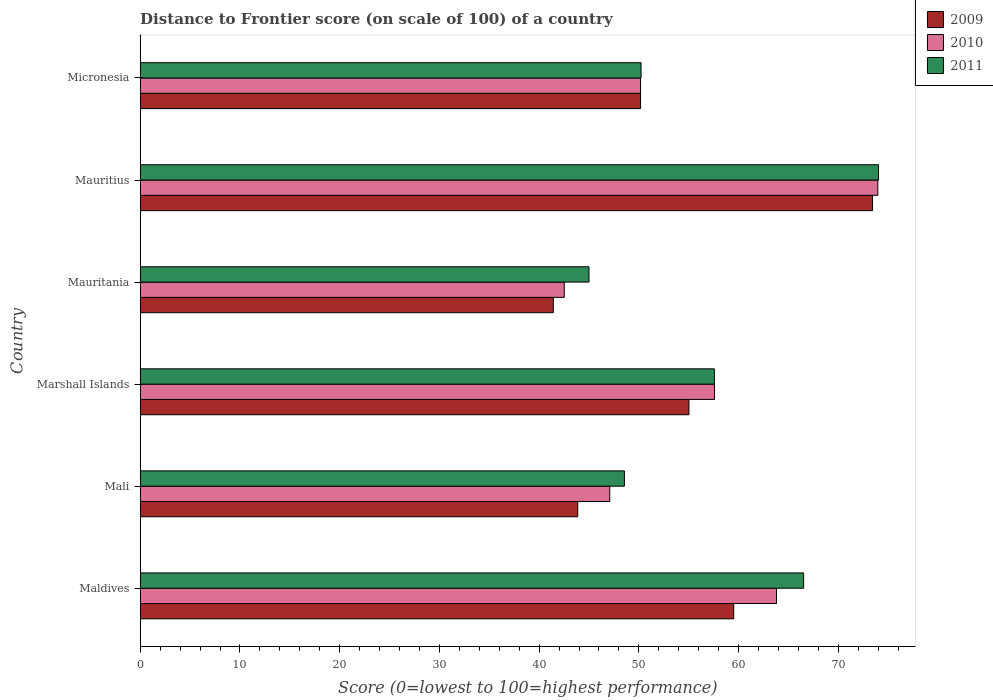How many bars are there on the 1st tick from the bottom?
Give a very brief answer. 3. What is the label of the 3rd group of bars from the top?
Provide a short and direct response. Mauritania. What is the distance to frontier score of in 2011 in Maldives?
Your answer should be compact. 66.52. Across all countries, what is the maximum distance to frontier score of in 2011?
Your answer should be compact. 74.03. In which country was the distance to frontier score of in 2009 maximum?
Offer a terse response. Mauritius. In which country was the distance to frontier score of in 2010 minimum?
Offer a terse response. Mauritania. What is the total distance to frontier score of in 2011 in the graph?
Give a very brief answer. 341.89. What is the difference between the distance to frontier score of in 2010 in Maldives and that in Micronesia?
Ensure brevity in your answer.  13.63. What is the difference between the distance to frontier score of in 2011 in Micronesia and the distance to frontier score of in 2009 in Maldives?
Give a very brief answer. -9.29. What is the average distance to frontier score of in 2010 per country?
Your response must be concise. 55.85. What is the difference between the distance to frontier score of in 2009 and distance to frontier score of in 2010 in Mauritania?
Your answer should be compact. -1.1. What is the ratio of the distance to frontier score of in 2011 in Marshall Islands to that in Mauritius?
Ensure brevity in your answer.  0.78. Is the distance to frontier score of in 2009 in Marshall Islands less than that in Mauritius?
Give a very brief answer. Yes. Is the difference between the distance to frontier score of in 2009 in Mali and Micronesia greater than the difference between the distance to frontier score of in 2010 in Mali and Micronesia?
Your answer should be compact. No. What is the difference between the highest and the second highest distance to frontier score of in 2010?
Keep it short and to the point. 10.16. What is the difference between the highest and the lowest distance to frontier score of in 2010?
Provide a short and direct response. 31.44. What does the 1st bar from the top in Mauritania represents?
Offer a very short reply. 2011. Is it the case that in every country, the sum of the distance to frontier score of in 2009 and distance to frontier score of in 2010 is greater than the distance to frontier score of in 2011?
Offer a very short reply. Yes. How many bars are there?
Provide a succinct answer. 18. What is the difference between two consecutive major ticks on the X-axis?
Make the answer very short. 10. Does the graph contain grids?
Your response must be concise. No. Where does the legend appear in the graph?
Offer a terse response. Top right. How many legend labels are there?
Your answer should be compact. 3. How are the legend labels stacked?
Provide a succinct answer. Vertical. What is the title of the graph?
Offer a terse response. Distance to Frontier score (on scale of 100) of a country. Does "2012" appear as one of the legend labels in the graph?
Your answer should be very brief. No. What is the label or title of the X-axis?
Make the answer very short. Score (0=lowest to 100=highest performance). What is the label or title of the Y-axis?
Offer a very short reply. Country. What is the Score (0=lowest to 100=highest performance) of 2009 in Maldives?
Give a very brief answer. 59.51. What is the Score (0=lowest to 100=highest performance) of 2010 in Maldives?
Give a very brief answer. 63.8. What is the Score (0=lowest to 100=highest performance) in 2011 in Maldives?
Give a very brief answer. 66.52. What is the Score (0=lowest to 100=highest performance) in 2009 in Mali?
Your response must be concise. 43.87. What is the Score (0=lowest to 100=highest performance) in 2010 in Mali?
Offer a very short reply. 47.08. What is the Score (0=lowest to 100=highest performance) in 2011 in Mali?
Your answer should be compact. 48.55. What is the Score (0=lowest to 100=highest performance) in 2009 in Marshall Islands?
Offer a terse response. 55.02. What is the Score (0=lowest to 100=highest performance) in 2010 in Marshall Islands?
Your answer should be compact. 57.58. What is the Score (0=lowest to 100=highest performance) of 2011 in Marshall Islands?
Keep it short and to the point. 57.57. What is the Score (0=lowest to 100=highest performance) in 2009 in Mauritania?
Your response must be concise. 41.42. What is the Score (0=lowest to 100=highest performance) of 2010 in Mauritania?
Your answer should be compact. 42.52. What is the Score (0=lowest to 100=highest performance) of 2011 in Mauritania?
Your answer should be compact. 45. What is the Score (0=lowest to 100=highest performance) of 2009 in Mauritius?
Make the answer very short. 73.43. What is the Score (0=lowest to 100=highest performance) of 2010 in Mauritius?
Ensure brevity in your answer.  73.96. What is the Score (0=lowest to 100=highest performance) in 2011 in Mauritius?
Provide a succinct answer. 74.03. What is the Score (0=lowest to 100=highest performance) in 2009 in Micronesia?
Provide a short and direct response. 50.17. What is the Score (0=lowest to 100=highest performance) in 2010 in Micronesia?
Offer a very short reply. 50.17. What is the Score (0=lowest to 100=highest performance) in 2011 in Micronesia?
Your answer should be compact. 50.22. Across all countries, what is the maximum Score (0=lowest to 100=highest performance) in 2009?
Your response must be concise. 73.43. Across all countries, what is the maximum Score (0=lowest to 100=highest performance) of 2010?
Your response must be concise. 73.96. Across all countries, what is the maximum Score (0=lowest to 100=highest performance) of 2011?
Keep it short and to the point. 74.03. Across all countries, what is the minimum Score (0=lowest to 100=highest performance) of 2009?
Ensure brevity in your answer.  41.42. Across all countries, what is the minimum Score (0=lowest to 100=highest performance) of 2010?
Make the answer very short. 42.52. What is the total Score (0=lowest to 100=highest performance) of 2009 in the graph?
Give a very brief answer. 323.42. What is the total Score (0=lowest to 100=highest performance) of 2010 in the graph?
Ensure brevity in your answer.  335.11. What is the total Score (0=lowest to 100=highest performance) in 2011 in the graph?
Ensure brevity in your answer.  341.89. What is the difference between the Score (0=lowest to 100=highest performance) in 2009 in Maldives and that in Mali?
Your response must be concise. 15.64. What is the difference between the Score (0=lowest to 100=highest performance) in 2010 in Maldives and that in Mali?
Your response must be concise. 16.72. What is the difference between the Score (0=lowest to 100=highest performance) in 2011 in Maldives and that in Mali?
Provide a succinct answer. 17.97. What is the difference between the Score (0=lowest to 100=highest performance) in 2009 in Maldives and that in Marshall Islands?
Your answer should be compact. 4.49. What is the difference between the Score (0=lowest to 100=highest performance) in 2010 in Maldives and that in Marshall Islands?
Keep it short and to the point. 6.22. What is the difference between the Score (0=lowest to 100=highest performance) in 2011 in Maldives and that in Marshall Islands?
Offer a terse response. 8.95. What is the difference between the Score (0=lowest to 100=highest performance) of 2009 in Maldives and that in Mauritania?
Your answer should be very brief. 18.09. What is the difference between the Score (0=lowest to 100=highest performance) of 2010 in Maldives and that in Mauritania?
Offer a terse response. 21.28. What is the difference between the Score (0=lowest to 100=highest performance) in 2011 in Maldives and that in Mauritania?
Your answer should be compact. 21.52. What is the difference between the Score (0=lowest to 100=highest performance) in 2009 in Maldives and that in Mauritius?
Give a very brief answer. -13.92. What is the difference between the Score (0=lowest to 100=highest performance) in 2010 in Maldives and that in Mauritius?
Your answer should be compact. -10.16. What is the difference between the Score (0=lowest to 100=highest performance) in 2011 in Maldives and that in Mauritius?
Give a very brief answer. -7.51. What is the difference between the Score (0=lowest to 100=highest performance) in 2009 in Maldives and that in Micronesia?
Your answer should be compact. 9.34. What is the difference between the Score (0=lowest to 100=highest performance) in 2010 in Maldives and that in Micronesia?
Your answer should be compact. 13.63. What is the difference between the Score (0=lowest to 100=highest performance) in 2011 in Maldives and that in Micronesia?
Provide a short and direct response. 16.3. What is the difference between the Score (0=lowest to 100=highest performance) in 2009 in Mali and that in Marshall Islands?
Provide a succinct answer. -11.15. What is the difference between the Score (0=lowest to 100=highest performance) of 2011 in Mali and that in Marshall Islands?
Your response must be concise. -9.02. What is the difference between the Score (0=lowest to 100=highest performance) of 2009 in Mali and that in Mauritania?
Provide a short and direct response. 2.45. What is the difference between the Score (0=lowest to 100=highest performance) of 2010 in Mali and that in Mauritania?
Offer a terse response. 4.56. What is the difference between the Score (0=lowest to 100=highest performance) in 2011 in Mali and that in Mauritania?
Your response must be concise. 3.55. What is the difference between the Score (0=lowest to 100=highest performance) of 2009 in Mali and that in Mauritius?
Offer a very short reply. -29.56. What is the difference between the Score (0=lowest to 100=highest performance) of 2010 in Mali and that in Mauritius?
Your answer should be very brief. -26.88. What is the difference between the Score (0=lowest to 100=highest performance) of 2011 in Mali and that in Mauritius?
Ensure brevity in your answer.  -25.48. What is the difference between the Score (0=lowest to 100=highest performance) in 2009 in Mali and that in Micronesia?
Your answer should be very brief. -6.3. What is the difference between the Score (0=lowest to 100=highest performance) in 2010 in Mali and that in Micronesia?
Your answer should be compact. -3.09. What is the difference between the Score (0=lowest to 100=highest performance) of 2011 in Mali and that in Micronesia?
Make the answer very short. -1.67. What is the difference between the Score (0=lowest to 100=highest performance) of 2009 in Marshall Islands and that in Mauritania?
Keep it short and to the point. 13.6. What is the difference between the Score (0=lowest to 100=highest performance) of 2010 in Marshall Islands and that in Mauritania?
Give a very brief answer. 15.06. What is the difference between the Score (0=lowest to 100=highest performance) in 2011 in Marshall Islands and that in Mauritania?
Offer a terse response. 12.57. What is the difference between the Score (0=lowest to 100=highest performance) of 2009 in Marshall Islands and that in Mauritius?
Provide a short and direct response. -18.41. What is the difference between the Score (0=lowest to 100=highest performance) of 2010 in Marshall Islands and that in Mauritius?
Provide a succinct answer. -16.38. What is the difference between the Score (0=lowest to 100=highest performance) in 2011 in Marshall Islands and that in Mauritius?
Offer a terse response. -16.46. What is the difference between the Score (0=lowest to 100=highest performance) of 2009 in Marshall Islands and that in Micronesia?
Provide a short and direct response. 4.85. What is the difference between the Score (0=lowest to 100=highest performance) in 2010 in Marshall Islands and that in Micronesia?
Keep it short and to the point. 7.41. What is the difference between the Score (0=lowest to 100=highest performance) in 2011 in Marshall Islands and that in Micronesia?
Keep it short and to the point. 7.35. What is the difference between the Score (0=lowest to 100=highest performance) in 2009 in Mauritania and that in Mauritius?
Ensure brevity in your answer.  -32.01. What is the difference between the Score (0=lowest to 100=highest performance) of 2010 in Mauritania and that in Mauritius?
Your response must be concise. -31.44. What is the difference between the Score (0=lowest to 100=highest performance) in 2011 in Mauritania and that in Mauritius?
Provide a succinct answer. -29.03. What is the difference between the Score (0=lowest to 100=highest performance) in 2009 in Mauritania and that in Micronesia?
Your response must be concise. -8.75. What is the difference between the Score (0=lowest to 100=highest performance) of 2010 in Mauritania and that in Micronesia?
Offer a terse response. -7.65. What is the difference between the Score (0=lowest to 100=highest performance) of 2011 in Mauritania and that in Micronesia?
Keep it short and to the point. -5.22. What is the difference between the Score (0=lowest to 100=highest performance) in 2009 in Mauritius and that in Micronesia?
Provide a short and direct response. 23.26. What is the difference between the Score (0=lowest to 100=highest performance) of 2010 in Mauritius and that in Micronesia?
Provide a succinct answer. 23.79. What is the difference between the Score (0=lowest to 100=highest performance) in 2011 in Mauritius and that in Micronesia?
Your answer should be very brief. 23.81. What is the difference between the Score (0=lowest to 100=highest performance) of 2009 in Maldives and the Score (0=lowest to 100=highest performance) of 2010 in Mali?
Provide a short and direct response. 12.43. What is the difference between the Score (0=lowest to 100=highest performance) in 2009 in Maldives and the Score (0=lowest to 100=highest performance) in 2011 in Mali?
Offer a terse response. 10.96. What is the difference between the Score (0=lowest to 100=highest performance) in 2010 in Maldives and the Score (0=lowest to 100=highest performance) in 2011 in Mali?
Keep it short and to the point. 15.25. What is the difference between the Score (0=lowest to 100=highest performance) of 2009 in Maldives and the Score (0=lowest to 100=highest performance) of 2010 in Marshall Islands?
Provide a succinct answer. 1.93. What is the difference between the Score (0=lowest to 100=highest performance) of 2009 in Maldives and the Score (0=lowest to 100=highest performance) of 2011 in Marshall Islands?
Provide a short and direct response. 1.94. What is the difference between the Score (0=lowest to 100=highest performance) of 2010 in Maldives and the Score (0=lowest to 100=highest performance) of 2011 in Marshall Islands?
Keep it short and to the point. 6.23. What is the difference between the Score (0=lowest to 100=highest performance) in 2009 in Maldives and the Score (0=lowest to 100=highest performance) in 2010 in Mauritania?
Your response must be concise. 16.99. What is the difference between the Score (0=lowest to 100=highest performance) of 2009 in Maldives and the Score (0=lowest to 100=highest performance) of 2011 in Mauritania?
Keep it short and to the point. 14.51. What is the difference between the Score (0=lowest to 100=highest performance) of 2010 in Maldives and the Score (0=lowest to 100=highest performance) of 2011 in Mauritania?
Your answer should be compact. 18.8. What is the difference between the Score (0=lowest to 100=highest performance) of 2009 in Maldives and the Score (0=lowest to 100=highest performance) of 2010 in Mauritius?
Ensure brevity in your answer.  -14.45. What is the difference between the Score (0=lowest to 100=highest performance) of 2009 in Maldives and the Score (0=lowest to 100=highest performance) of 2011 in Mauritius?
Your response must be concise. -14.52. What is the difference between the Score (0=lowest to 100=highest performance) in 2010 in Maldives and the Score (0=lowest to 100=highest performance) in 2011 in Mauritius?
Keep it short and to the point. -10.23. What is the difference between the Score (0=lowest to 100=highest performance) of 2009 in Maldives and the Score (0=lowest to 100=highest performance) of 2010 in Micronesia?
Make the answer very short. 9.34. What is the difference between the Score (0=lowest to 100=highest performance) in 2009 in Maldives and the Score (0=lowest to 100=highest performance) in 2011 in Micronesia?
Offer a terse response. 9.29. What is the difference between the Score (0=lowest to 100=highest performance) in 2010 in Maldives and the Score (0=lowest to 100=highest performance) in 2011 in Micronesia?
Offer a very short reply. 13.58. What is the difference between the Score (0=lowest to 100=highest performance) of 2009 in Mali and the Score (0=lowest to 100=highest performance) of 2010 in Marshall Islands?
Keep it short and to the point. -13.71. What is the difference between the Score (0=lowest to 100=highest performance) in 2009 in Mali and the Score (0=lowest to 100=highest performance) in 2011 in Marshall Islands?
Provide a succinct answer. -13.7. What is the difference between the Score (0=lowest to 100=highest performance) in 2010 in Mali and the Score (0=lowest to 100=highest performance) in 2011 in Marshall Islands?
Give a very brief answer. -10.49. What is the difference between the Score (0=lowest to 100=highest performance) of 2009 in Mali and the Score (0=lowest to 100=highest performance) of 2010 in Mauritania?
Provide a succinct answer. 1.35. What is the difference between the Score (0=lowest to 100=highest performance) of 2009 in Mali and the Score (0=lowest to 100=highest performance) of 2011 in Mauritania?
Provide a short and direct response. -1.13. What is the difference between the Score (0=lowest to 100=highest performance) in 2010 in Mali and the Score (0=lowest to 100=highest performance) in 2011 in Mauritania?
Provide a succinct answer. 2.08. What is the difference between the Score (0=lowest to 100=highest performance) of 2009 in Mali and the Score (0=lowest to 100=highest performance) of 2010 in Mauritius?
Offer a very short reply. -30.09. What is the difference between the Score (0=lowest to 100=highest performance) of 2009 in Mali and the Score (0=lowest to 100=highest performance) of 2011 in Mauritius?
Your answer should be compact. -30.16. What is the difference between the Score (0=lowest to 100=highest performance) in 2010 in Mali and the Score (0=lowest to 100=highest performance) in 2011 in Mauritius?
Your answer should be very brief. -26.95. What is the difference between the Score (0=lowest to 100=highest performance) of 2009 in Mali and the Score (0=lowest to 100=highest performance) of 2011 in Micronesia?
Give a very brief answer. -6.35. What is the difference between the Score (0=lowest to 100=highest performance) of 2010 in Mali and the Score (0=lowest to 100=highest performance) of 2011 in Micronesia?
Offer a terse response. -3.14. What is the difference between the Score (0=lowest to 100=highest performance) in 2009 in Marshall Islands and the Score (0=lowest to 100=highest performance) in 2010 in Mauritania?
Your response must be concise. 12.5. What is the difference between the Score (0=lowest to 100=highest performance) of 2009 in Marshall Islands and the Score (0=lowest to 100=highest performance) of 2011 in Mauritania?
Keep it short and to the point. 10.02. What is the difference between the Score (0=lowest to 100=highest performance) in 2010 in Marshall Islands and the Score (0=lowest to 100=highest performance) in 2011 in Mauritania?
Your answer should be very brief. 12.58. What is the difference between the Score (0=lowest to 100=highest performance) of 2009 in Marshall Islands and the Score (0=lowest to 100=highest performance) of 2010 in Mauritius?
Keep it short and to the point. -18.94. What is the difference between the Score (0=lowest to 100=highest performance) in 2009 in Marshall Islands and the Score (0=lowest to 100=highest performance) in 2011 in Mauritius?
Give a very brief answer. -19.01. What is the difference between the Score (0=lowest to 100=highest performance) in 2010 in Marshall Islands and the Score (0=lowest to 100=highest performance) in 2011 in Mauritius?
Your response must be concise. -16.45. What is the difference between the Score (0=lowest to 100=highest performance) in 2009 in Marshall Islands and the Score (0=lowest to 100=highest performance) in 2010 in Micronesia?
Ensure brevity in your answer.  4.85. What is the difference between the Score (0=lowest to 100=highest performance) in 2009 in Marshall Islands and the Score (0=lowest to 100=highest performance) in 2011 in Micronesia?
Keep it short and to the point. 4.8. What is the difference between the Score (0=lowest to 100=highest performance) of 2010 in Marshall Islands and the Score (0=lowest to 100=highest performance) of 2011 in Micronesia?
Keep it short and to the point. 7.36. What is the difference between the Score (0=lowest to 100=highest performance) in 2009 in Mauritania and the Score (0=lowest to 100=highest performance) in 2010 in Mauritius?
Offer a terse response. -32.54. What is the difference between the Score (0=lowest to 100=highest performance) of 2009 in Mauritania and the Score (0=lowest to 100=highest performance) of 2011 in Mauritius?
Give a very brief answer. -32.61. What is the difference between the Score (0=lowest to 100=highest performance) of 2010 in Mauritania and the Score (0=lowest to 100=highest performance) of 2011 in Mauritius?
Your response must be concise. -31.51. What is the difference between the Score (0=lowest to 100=highest performance) of 2009 in Mauritania and the Score (0=lowest to 100=highest performance) of 2010 in Micronesia?
Give a very brief answer. -8.75. What is the difference between the Score (0=lowest to 100=highest performance) in 2009 in Mauritania and the Score (0=lowest to 100=highest performance) in 2011 in Micronesia?
Your answer should be very brief. -8.8. What is the difference between the Score (0=lowest to 100=highest performance) of 2009 in Mauritius and the Score (0=lowest to 100=highest performance) of 2010 in Micronesia?
Ensure brevity in your answer.  23.26. What is the difference between the Score (0=lowest to 100=highest performance) of 2009 in Mauritius and the Score (0=lowest to 100=highest performance) of 2011 in Micronesia?
Your response must be concise. 23.21. What is the difference between the Score (0=lowest to 100=highest performance) of 2010 in Mauritius and the Score (0=lowest to 100=highest performance) of 2011 in Micronesia?
Your answer should be very brief. 23.74. What is the average Score (0=lowest to 100=highest performance) in 2009 per country?
Ensure brevity in your answer.  53.9. What is the average Score (0=lowest to 100=highest performance) in 2010 per country?
Your response must be concise. 55.85. What is the average Score (0=lowest to 100=highest performance) in 2011 per country?
Your answer should be very brief. 56.98. What is the difference between the Score (0=lowest to 100=highest performance) in 2009 and Score (0=lowest to 100=highest performance) in 2010 in Maldives?
Give a very brief answer. -4.29. What is the difference between the Score (0=lowest to 100=highest performance) in 2009 and Score (0=lowest to 100=highest performance) in 2011 in Maldives?
Give a very brief answer. -7.01. What is the difference between the Score (0=lowest to 100=highest performance) in 2010 and Score (0=lowest to 100=highest performance) in 2011 in Maldives?
Provide a short and direct response. -2.72. What is the difference between the Score (0=lowest to 100=highest performance) of 2009 and Score (0=lowest to 100=highest performance) of 2010 in Mali?
Keep it short and to the point. -3.21. What is the difference between the Score (0=lowest to 100=highest performance) of 2009 and Score (0=lowest to 100=highest performance) of 2011 in Mali?
Provide a short and direct response. -4.68. What is the difference between the Score (0=lowest to 100=highest performance) in 2010 and Score (0=lowest to 100=highest performance) in 2011 in Mali?
Your response must be concise. -1.47. What is the difference between the Score (0=lowest to 100=highest performance) in 2009 and Score (0=lowest to 100=highest performance) in 2010 in Marshall Islands?
Provide a succinct answer. -2.56. What is the difference between the Score (0=lowest to 100=highest performance) in 2009 and Score (0=lowest to 100=highest performance) in 2011 in Marshall Islands?
Offer a very short reply. -2.55. What is the difference between the Score (0=lowest to 100=highest performance) of 2010 and Score (0=lowest to 100=highest performance) of 2011 in Marshall Islands?
Provide a short and direct response. 0.01. What is the difference between the Score (0=lowest to 100=highest performance) of 2009 and Score (0=lowest to 100=highest performance) of 2011 in Mauritania?
Provide a short and direct response. -3.58. What is the difference between the Score (0=lowest to 100=highest performance) in 2010 and Score (0=lowest to 100=highest performance) in 2011 in Mauritania?
Offer a very short reply. -2.48. What is the difference between the Score (0=lowest to 100=highest performance) of 2009 and Score (0=lowest to 100=highest performance) of 2010 in Mauritius?
Your response must be concise. -0.53. What is the difference between the Score (0=lowest to 100=highest performance) in 2010 and Score (0=lowest to 100=highest performance) in 2011 in Mauritius?
Offer a very short reply. -0.07. What is the ratio of the Score (0=lowest to 100=highest performance) in 2009 in Maldives to that in Mali?
Your answer should be compact. 1.36. What is the ratio of the Score (0=lowest to 100=highest performance) of 2010 in Maldives to that in Mali?
Make the answer very short. 1.36. What is the ratio of the Score (0=lowest to 100=highest performance) of 2011 in Maldives to that in Mali?
Provide a short and direct response. 1.37. What is the ratio of the Score (0=lowest to 100=highest performance) in 2009 in Maldives to that in Marshall Islands?
Make the answer very short. 1.08. What is the ratio of the Score (0=lowest to 100=highest performance) in 2010 in Maldives to that in Marshall Islands?
Your response must be concise. 1.11. What is the ratio of the Score (0=lowest to 100=highest performance) in 2011 in Maldives to that in Marshall Islands?
Make the answer very short. 1.16. What is the ratio of the Score (0=lowest to 100=highest performance) in 2009 in Maldives to that in Mauritania?
Offer a very short reply. 1.44. What is the ratio of the Score (0=lowest to 100=highest performance) of 2010 in Maldives to that in Mauritania?
Your answer should be compact. 1.5. What is the ratio of the Score (0=lowest to 100=highest performance) in 2011 in Maldives to that in Mauritania?
Offer a terse response. 1.48. What is the ratio of the Score (0=lowest to 100=highest performance) in 2009 in Maldives to that in Mauritius?
Your answer should be very brief. 0.81. What is the ratio of the Score (0=lowest to 100=highest performance) of 2010 in Maldives to that in Mauritius?
Your answer should be very brief. 0.86. What is the ratio of the Score (0=lowest to 100=highest performance) of 2011 in Maldives to that in Mauritius?
Your answer should be very brief. 0.9. What is the ratio of the Score (0=lowest to 100=highest performance) of 2009 in Maldives to that in Micronesia?
Provide a short and direct response. 1.19. What is the ratio of the Score (0=lowest to 100=highest performance) in 2010 in Maldives to that in Micronesia?
Keep it short and to the point. 1.27. What is the ratio of the Score (0=lowest to 100=highest performance) in 2011 in Maldives to that in Micronesia?
Ensure brevity in your answer.  1.32. What is the ratio of the Score (0=lowest to 100=highest performance) in 2009 in Mali to that in Marshall Islands?
Your answer should be very brief. 0.8. What is the ratio of the Score (0=lowest to 100=highest performance) in 2010 in Mali to that in Marshall Islands?
Provide a succinct answer. 0.82. What is the ratio of the Score (0=lowest to 100=highest performance) of 2011 in Mali to that in Marshall Islands?
Keep it short and to the point. 0.84. What is the ratio of the Score (0=lowest to 100=highest performance) in 2009 in Mali to that in Mauritania?
Your answer should be very brief. 1.06. What is the ratio of the Score (0=lowest to 100=highest performance) of 2010 in Mali to that in Mauritania?
Your response must be concise. 1.11. What is the ratio of the Score (0=lowest to 100=highest performance) in 2011 in Mali to that in Mauritania?
Provide a short and direct response. 1.08. What is the ratio of the Score (0=lowest to 100=highest performance) of 2009 in Mali to that in Mauritius?
Your answer should be very brief. 0.6. What is the ratio of the Score (0=lowest to 100=highest performance) in 2010 in Mali to that in Mauritius?
Keep it short and to the point. 0.64. What is the ratio of the Score (0=lowest to 100=highest performance) of 2011 in Mali to that in Mauritius?
Your answer should be compact. 0.66. What is the ratio of the Score (0=lowest to 100=highest performance) in 2009 in Mali to that in Micronesia?
Give a very brief answer. 0.87. What is the ratio of the Score (0=lowest to 100=highest performance) in 2010 in Mali to that in Micronesia?
Keep it short and to the point. 0.94. What is the ratio of the Score (0=lowest to 100=highest performance) in 2011 in Mali to that in Micronesia?
Make the answer very short. 0.97. What is the ratio of the Score (0=lowest to 100=highest performance) of 2009 in Marshall Islands to that in Mauritania?
Provide a succinct answer. 1.33. What is the ratio of the Score (0=lowest to 100=highest performance) of 2010 in Marshall Islands to that in Mauritania?
Your answer should be compact. 1.35. What is the ratio of the Score (0=lowest to 100=highest performance) in 2011 in Marshall Islands to that in Mauritania?
Offer a terse response. 1.28. What is the ratio of the Score (0=lowest to 100=highest performance) in 2009 in Marshall Islands to that in Mauritius?
Offer a very short reply. 0.75. What is the ratio of the Score (0=lowest to 100=highest performance) in 2010 in Marshall Islands to that in Mauritius?
Your answer should be compact. 0.78. What is the ratio of the Score (0=lowest to 100=highest performance) of 2011 in Marshall Islands to that in Mauritius?
Your answer should be compact. 0.78. What is the ratio of the Score (0=lowest to 100=highest performance) of 2009 in Marshall Islands to that in Micronesia?
Your answer should be compact. 1.1. What is the ratio of the Score (0=lowest to 100=highest performance) of 2010 in Marshall Islands to that in Micronesia?
Your response must be concise. 1.15. What is the ratio of the Score (0=lowest to 100=highest performance) of 2011 in Marshall Islands to that in Micronesia?
Offer a very short reply. 1.15. What is the ratio of the Score (0=lowest to 100=highest performance) of 2009 in Mauritania to that in Mauritius?
Offer a very short reply. 0.56. What is the ratio of the Score (0=lowest to 100=highest performance) of 2010 in Mauritania to that in Mauritius?
Provide a succinct answer. 0.57. What is the ratio of the Score (0=lowest to 100=highest performance) in 2011 in Mauritania to that in Mauritius?
Provide a short and direct response. 0.61. What is the ratio of the Score (0=lowest to 100=highest performance) in 2009 in Mauritania to that in Micronesia?
Your answer should be very brief. 0.83. What is the ratio of the Score (0=lowest to 100=highest performance) in 2010 in Mauritania to that in Micronesia?
Provide a succinct answer. 0.85. What is the ratio of the Score (0=lowest to 100=highest performance) of 2011 in Mauritania to that in Micronesia?
Give a very brief answer. 0.9. What is the ratio of the Score (0=lowest to 100=highest performance) in 2009 in Mauritius to that in Micronesia?
Make the answer very short. 1.46. What is the ratio of the Score (0=lowest to 100=highest performance) in 2010 in Mauritius to that in Micronesia?
Offer a very short reply. 1.47. What is the ratio of the Score (0=lowest to 100=highest performance) of 2011 in Mauritius to that in Micronesia?
Your response must be concise. 1.47. What is the difference between the highest and the second highest Score (0=lowest to 100=highest performance) in 2009?
Make the answer very short. 13.92. What is the difference between the highest and the second highest Score (0=lowest to 100=highest performance) of 2010?
Your response must be concise. 10.16. What is the difference between the highest and the second highest Score (0=lowest to 100=highest performance) in 2011?
Offer a very short reply. 7.51. What is the difference between the highest and the lowest Score (0=lowest to 100=highest performance) of 2009?
Give a very brief answer. 32.01. What is the difference between the highest and the lowest Score (0=lowest to 100=highest performance) in 2010?
Provide a succinct answer. 31.44. What is the difference between the highest and the lowest Score (0=lowest to 100=highest performance) in 2011?
Provide a short and direct response. 29.03. 